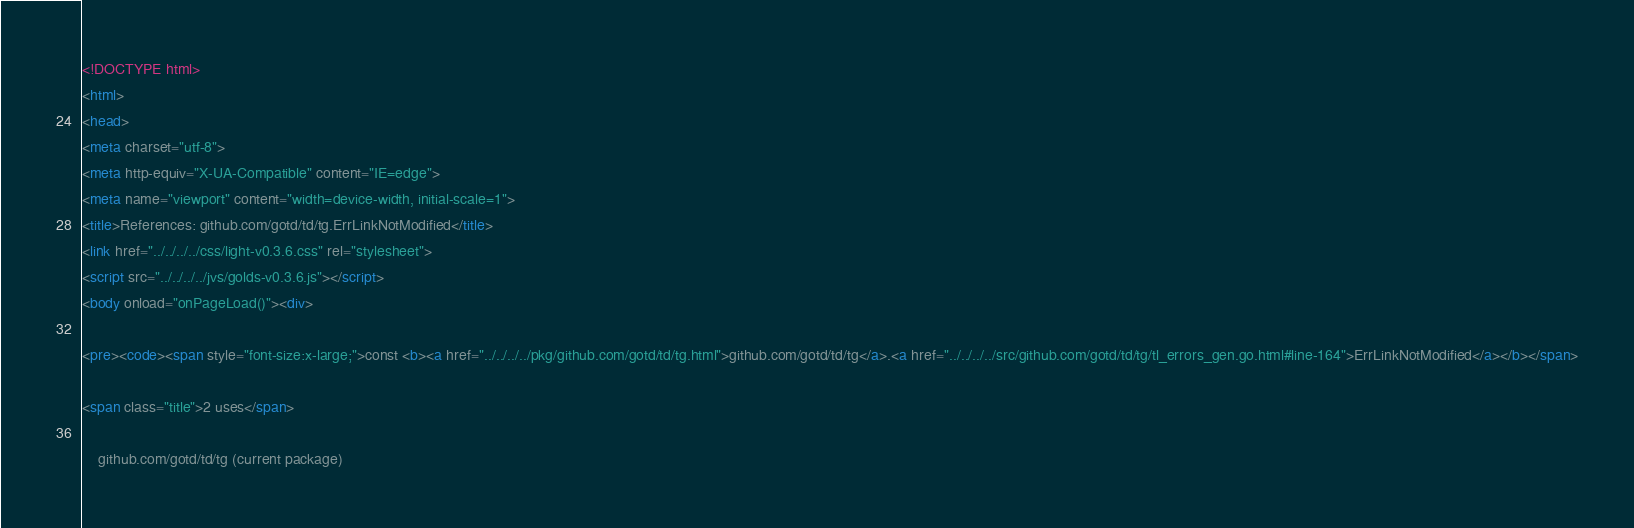<code> <loc_0><loc_0><loc_500><loc_500><_HTML_><!DOCTYPE html>
<html>
<head>
<meta charset="utf-8">
<meta http-equiv="X-UA-Compatible" content="IE=edge">
<meta name="viewport" content="width=device-width, initial-scale=1">
<title>References: github.com/gotd/td/tg.ErrLinkNotModified</title>
<link href="../../../../css/light-v0.3.6.css" rel="stylesheet">
<script src="../../../../jvs/golds-v0.3.6.js"></script>
<body onload="onPageLoad()"><div>

<pre><code><span style="font-size:x-large;">const <b><a href="../../../../pkg/github.com/gotd/td/tg.html">github.com/gotd/td/tg</a>.<a href="../../../../src/github.com/gotd/td/tg/tl_errors_gen.go.html#line-164">ErrLinkNotModified</a></b></span>

<span class="title">2 uses</span>

	github.com/gotd/td/tg (current package)</code> 